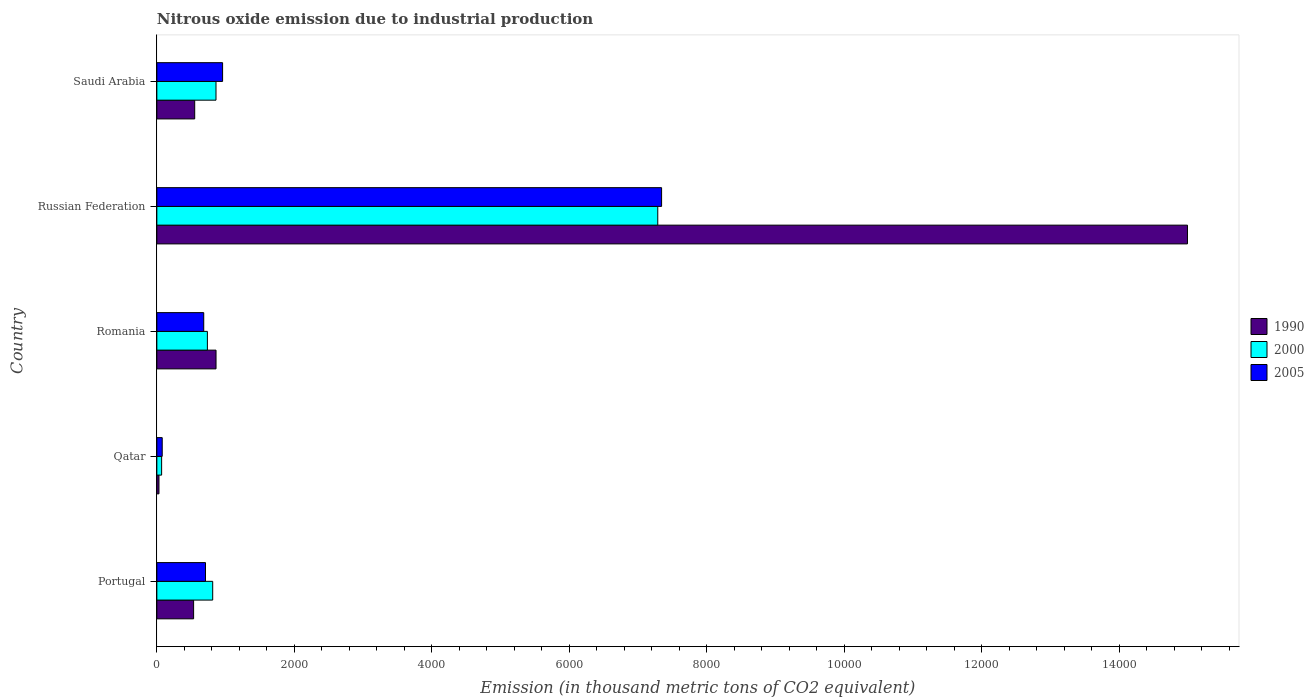How many groups of bars are there?
Ensure brevity in your answer.  5. How many bars are there on the 3rd tick from the bottom?
Your answer should be compact. 3. What is the label of the 4th group of bars from the top?
Make the answer very short. Qatar. What is the amount of nitrous oxide emitted in 2000 in Qatar?
Offer a terse response. 69.5. Across all countries, what is the maximum amount of nitrous oxide emitted in 1990?
Your answer should be compact. 1.50e+04. Across all countries, what is the minimum amount of nitrous oxide emitted in 2005?
Provide a short and direct response. 78.2. In which country was the amount of nitrous oxide emitted in 2000 maximum?
Provide a succinct answer. Russian Federation. In which country was the amount of nitrous oxide emitted in 2005 minimum?
Your response must be concise. Qatar. What is the total amount of nitrous oxide emitted in 2000 in the graph?
Offer a terse response. 9766.6. What is the difference between the amount of nitrous oxide emitted in 2005 in Qatar and that in Saudi Arabia?
Offer a terse response. -878.5. What is the difference between the amount of nitrous oxide emitted in 2000 in Qatar and the amount of nitrous oxide emitted in 2005 in Portugal?
Provide a succinct answer. -638.5. What is the average amount of nitrous oxide emitted in 2000 per country?
Your response must be concise. 1953.32. What is the difference between the amount of nitrous oxide emitted in 2005 and amount of nitrous oxide emitted in 1990 in Portugal?
Offer a very short reply. 173.1. What is the ratio of the amount of nitrous oxide emitted in 2005 in Russian Federation to that in Saudi Arabia?
Keep it short and to the point. 7.68. Is the amount of nitrous oxide emitted in 1990 in Portugal less than that in Russian Federation?
Provide a short and direct response. Yes. What is the difference between the highest and the second highest amount of nitrous oxide emitted in 1990?
Your answer should be compact. 1.41e+04. What is the difference between the highest and the lowest amount of nitrous oxide emitted in 1990?
Keep it short and to the point. 1.50e+04. What does the 1st bar from the top in Qatar represents?
Your answer should be very brief. 2005. Is it the case that in every country, the sum of the amount of nitrous oxide emitted in 2005 and amount of nitrous oxide emitted in 1990 is greater than the amount of nitrous oxide emitted in 2000?
Your response must be concise. Yes. How many bars are there?
Give a very brief answer. 15. Are all the bars in the graph horizontal?
Provide a short and direct response. Yes. Are the values on the major ticks of X-axis written in scientific E-notation?
Your response must be concise. No. Does the graph contain any zero values?
Your answer should be very brief. No. Does the graph contain grids?
Your answer should be very brief. No. How are the legend labels stacked?
Offer a very short reply. Vertical. What is the title of the graph?
Offer a terse response. Nitrous oxide emission due to industrial production. What is the label or title of the X-axis?
Your answer should be compact. Emission (in thousand metric tons of CO2 equivalent). What is the label or title of the Y-axis?
Offer a terse response. Country. What is the Emission (in thousand metric tons of CO2 equivalent) in 1990 in Portugal?
Keep it short and to the point. 534.9. What is the Emission (in thousand metric tons of CO2 equivalent) in 2000 in Portugal?
Your answer should be very brief. 812.7. What is the Emission (in thousand metric tons of CO2 equivalent) in 2005 in Portugal?
Offer a terse response. 708. What is the Emission (in thousand metric tons of CO2 equivalent) in 1990 in Qatar?
Provide a succinct answer. 30.8. What is the Emission (in thousand metric tons of CO2 equivalent) of 2000 in Qatar?
Offer a terse response. 69.5. What is the Emission (in thousand metric tons of CO2 equivalent) in 2005 in Qatar?
Your answer should be very brief. 78.2. What is the Emission (in thousand metric tons of CO2 equivalent) in 1990 in Romania?
Your response must be concise. 861.1. What is the Emission (in thousand metric tons of CO2 equivalent) of 2000 in Romania?
Provide a succinct answer. 735.3. What is the Emission (in thousand metric tons of CO2 equivalent) in 2005 in Romania?
Give a very brief answer. 682.3. What is the Emission (in thousand metric tons of CO2 equivalent) in 1990 in Russian Federation?
Your answer should be very brief. 1.50e+04. What is the Emission (in thousand metric tons of CO2 equivalent) of 2000 in Russian Federation?
Give a very brief answer. 7288.4. What is the Emission (in thousand metric tons of CO2 equivalent) of 2005 in Russian Federation?
Offer a terse response. 7344.1. What is the Emission (in thousand metric tons of CO2 equivalent) of 1990 in Saudi Arabia?
Give a very brief answer. 550.9. What is the Emission (in thousand metric tons of CO2 equivalent) of 2000 in Saudi Arabia?
Provide a succinct answer. 860.7. What is the Emission (in thousand metric tons of CO2 equivalent) in 2005 in Saudi Arabia?
Your answer should be very brief. 956.7. Across all countries, what is the maximum Emission (in thousand metric tons of CO2 equivalent) of 1990?
Give a very brief answer. 1.50e+04. Across all countries, what is the maximum Emission (in thousand metric tons of CO2 equivalent) in 2000?
Give a very brief answer. 7288.4. Across all countries, what is the maximum Emission (in thousand metric tons of CO2 equivalent) in 2005?
Provide a succinct answer. 7344.1. Across all countries, what is the minimum Emission (in thousand metric tons of CO2 equivalent) in 1990?
Your response must be concise. 30.8. Across all countries, what is the minimum Emission (in thousand metric tons of CO2 equivalent) in 2000?
Keep it short and to the point. 69.5. Across all countries, what is the minimum Emission (in thousand metric tons of CO2 equivalent) in 2005?
Your answer should be compact. 78.2. What is the total Emission (in thousand metric tons of CO2 equivalent) of 1990 in the graph?
Provide a short and direct response. 1.70e+04. What is the total Emission (in thousand metric tons of CO2 equivalent) of 2000 in the graph?
Keep it short and to the point. 9766.6. What is the total Emission (in thousand metric tons of CO2 equivalent) in 2005 in the graph?
Your answer should be compact. 9769.3. What is the difference between the Emission (in thousand metric tons of CO2 equivalent) in 1990 in Portugal and that in Qatar?
Ensure brevity in your answer.  504.1. What is the difference between the Emission (in thousand metric tons of CO2 equivalent) of 2000 in Portugal and that in Qatar?
Make the answer very short. 743.2. What is the difference between the Emission (in thousand metric tons of CO2 equivalent) in 2005 in Portugal and that in Qatar?
Offer a terse response. 629.8. What is the difference between the Emission (in thousand metric tons of CO2 equivalent) in 1990 in Portugal and that in Romania?
Provide a short and direct response. -326.2. What is the difference between the Emission (in thousand metric tons of CO2 equivalent) in 2000 in Portugal and that in Romania?
Offer a terse response. 77.4. What is the difference between the Emission (in thousand metric tons of CO2 equivalent) in 2005 in Portugal and that in Romania?
Provide a succinct answer. 25.7. What is the difference between the Emission (in thousand metric tons of CO2 equivalent) in 1990 in Portugal and that in Russian Federation?
Give a very brief answer. -1.45e+04. What is the difference between the Emission (in thousand metric tons of CO2 equivalent) of 2000 in Portugal and that in Russian Federation?
Offer a terse response. -6475.7. What is the difference between the Emission (in thousand metric tons of CO2 equivalent) of 2005 in Portugal and that in Russian Federation?
Your answer should be compact. -6636.1. What is the difference between the Emission (in thousand metric tons of CO2 equivalent) of 1990 in Portugal and that in Saudi Arabia?
Make the answer very short. -16. What is the difference between the Emission (in thousand metric tons of CO2 equivalent) in 2000 in Portugal and that in Saudi Arabia?
Offer a very short reply. -48. What is the difference between the Emission (in thousand metric tons of CO2 equivalent) in 2005 in Portugal and that in Saudi Arabia?
Provide a short and direct response. -248.7. What is the difference between the Emission (in thousand metric tons of CO2 equivalent) in 1990 in Qatar and that in Romania?
Provide a short and direct response. -830.3. What is the difference between the Emission (in thousand metric tons of CO2 equivalent) of 2000 in Qatar and that in Romania?
Keep it short and to the point. -665.8. What is the difference between the Emission (in thousand metric tons of CO2 equivalent) of 2005 in Qatar and that in Romania?
Your answer should be very brief. -604.1. What is the difference between the Emission (in thousand metric tons of CO2 equivalent) in 1990 in Qatar and that in Russian Federation?
Offer a very short reply. -1.50e+04. What is the difference between the Emission (in thousand metric tons of CO2 equivalent) of 2000 in Qatar and that in Russian Federation?
Keep it short and to the point. -7218.9. What is the difference between the Emission (in thousand metric tons of CO2 equivalent) of 2005 in Qatar and that in Russian Federation?
Provide a short and direct response. -7265.9. What is the difference between the Emission (in thousand metric tons of CO2 equivalent) in 1990 in Qatar and that in Saudi Arabia?
Offer a very short reply. -520.1. What is the difference between the Emission (in thousand metric tons of CO2 equivalent) of 2000 in Qatar and that in Saudi Arabia?
Make the answer very short. -791.2. What is the difference between the Emission (in thousand metric tons of CO2 equivalent) of 2005 in Qatar and that in Saudi Arabia?
Give a very brief answer. -878.5. What is the difference between the Emission (in thousand metric tons of CO2 equivalent) of 1990 in Romania and that in Russian Federation?
Offer a very short reply. -1.41e+04. What is the difference between the Emission (in thousand metric tons of CO2 equivalent) in 2000 in Romania and that in Russian Federation?
Your response must be concise. -6553.1. What is the difference between the Emission (in thousand metric tons of CO2 equivalent) of 2005 in Romania and that in Russian Federation?
Ensure brevity in your answer.  -6661.8. What is the difference between the Emission (in thousand metric tons of CO2 equivalent) in 1990 in Romania and that in Saudi Arabia?
Keep it short and to the point. 310.2. What is the difference between the Emission (in thousand metric tons of CO2 equivalent) of 2000 in Romania and that in Saudi Arabia?
Give a very brief answer. -125.4. What is the difference between the Emission (in thousand metric tons of CO2 equivalent) of 2005 in Romania and that in Saudi Arabia?
Offer a very short reply. -274.4. What is the difference between the Emission (in thousand metric tons of CO2 equivalent) of 1990 in Russian Federation and that in Saudi Arabia?
Your answer should be very brief. 1.44e+04. What is the difference between the Emission (in thousand metric tons of CO2 equivalent) of 2000 in Russian Federation and that in Saudi Arabia?
Offer a terse response. 6427.7. What is the difference between the Emission (in thousand metric tons of CO2 equivalent) in 2005 in Russian Federation and that in Saudi Arabia?
Provide a short and direct response. 6387.4. What is the difference between the Emission (in thousand metric tons of CO2 equivalent) of 1990 in Portugal and the Emission (in thousand metric tons of CO2 equivalent) of 2000 in Qatar?
Provide a short and direct response. 465.4. What is the difference between the Emission (in thousand metric tons of CO2 equivalent) in 1990 in Portugal and the Emission (in thousand metric tons of CO2 equivalent) in 2005 in Qatar?
Provide a succinct answer. 456.7. What is the difference between the Emission (in thousand metric tons of CO2 equivalent) in 2000 in Portugal and the Emission (in thousand metric tons of CO2 equivalent) in 2005 in Qatar?
Ensure brevity in your answer.  734.5. What is the difference between the Emission (in thousand metric tons of CO2 equivalent) of 1990 in Portugal and the Emission (in thousand metric tons of CO2 equivalent) of 2000 in Romania?
Your answer should be very brief. -200.4. What is the difference between the Emission (in thousand metric tons of CO2 equivalent) in 1990 in Portugal and the Emission (in thousand metric tons of CO2 equivalent) in 2005 in Romania?
Your answer should be very brief. -147.4. What is the difference between the Emission (in thousand metric tons of CO2 equivalent) in 2000 in Portugal and the Emission (in thousand metric tons of CO2 equivalent) in 2005 in Romania?
Ensure brevity in your answer.  130.4. What is the difference between the Emission (in thousand metric tons of CO2 equivalent) of 1990 in Portugal and the Emission (in thousand metric tons of CO2 equivalent) of 2000 in Russian Federation?
Ensure brevity in your answer.  -6753.5. What is the difference between the Emission (in thousand metric tons of CO2 equivalent) in 1990 in Portugal and the Emission (in thousand metric tons of CO2 equivalent) in 2005 in Russian Federation?
Ensure brevity in your answer.  -6809.2. What is the difference between the Emission (in thousand metric tons of CO2 equivalent) of 2000 in Portugal and the Emission (in thousand metric tons of CO2 equivalent) of 2005 in Russian Federation?
Ensure brevity in your answer.  -6531.4. What is the difference between the Emission (in thousand metric tons of CO2 equivalent) in 1990 in Portugal and the Emission (in thousand metric tons of CO2 equivalent) in 2000 in Saudi Arabia?
Give a very brief answer. -325.8. What is the difference between the Emission (in thousand metric tons of CO2 equivalent) in 1990 in Portugal and the Emission (in thousand metric tons of CO2 equivalent) in 2005 in Saudi Arabia?
Offer a terse response. -421.8. What is the difference between the Emission (in thousand metric tons of CO2 equivalent) in 2000 in Portugal and the Emission (in thousand metric tons of CO2 equivalent) in 2005 in Saudi Arabia?
Provide a succinct answer. -144. What is the difference between the Emission (in thousand metric tons of CO2 equivalent) in 1990 in Qatar and the Emission (in thousand metric tons of CO2 equivalent) in 2000 in Romania?
Your response must be concise. -704.5. What is the difference between the Emission (in thousand metric tons of CO2 equivalent) of 1990 in Qatar and the Emission (in thousand metric tons of CO2 equivalent) of 2005 in Romania?
Make the answer very short. -651.5. What is the difference between the Emission (in thousand metric tons of CO2 equivalent) in 2000 in Qatar and the Emission (in thousand metric tons of CO2 equivalent) in 2005 in Romania?
Offer a very short reply. -612.8. What is the difference between the Emission (in thousand metric tons of CO2 equivalent) in 1990 in Qatar and the Emission (in thousand metric tons of CO2 equivalent) in 2000 in Russian Federation?
Provide a succinct answer. -7257.6. What is the difference between the Emission (in thousand metric tons of CO2 equivalent) in 1990 in Qatar and the Emission (in thousand metric tons of CO2 equivalent) in 2005 in Russian Federation?
Ensure brevity in your answer.  -7313.3. What is the difference between the Emission (in thousand metric tons of CO2 equivalent) in 2000 in Qatar and the Emission (in thousand metric tons of CO2 equivalent) in 2005 in Russian Federation?
Your answer should be very brief. -7274.6. What is the difference between the Emission (in thousand metric tons of CO2 equivalent) in 1990 in Qatar and the Emission (in thousand metric tons of CO2 equivalent) in 2000 in Saudi Arabia?
Provide a succinct answer. -829.9. What is the difference between the Emission (in thousand metric tons of CO2 equivalent) in 1990 in Qatar and the Emission (in thousand metric tons of CO2 equivalent) in 2005 in Saudi Arabia?
Keep it short and to the point. -925.9. What is the difference between the Emission (in thousand metric tons of CO2 equivalent) in 2000 in Qatar and the Emission (in thousand metric tons of CO2 equivalent) in 2005 in Saudi Arabia?
Give a very brief answer. -887.2. What is the difference between the Emission (in thousand metric tons of CO2 equivalent) of 1990 in Romania and the Emission (in thousand metric tons of CO2 equivalent) of 2000 in Russian Federation?
Your answer should be compact. -6427.3. What is the difference between the Emission (in thousand metric tons of CO2 equivalent) in 1990 in Romania and the Emission (in thousand metric tons of CO2 equivalent) in 2005 in Russian Federation?
Your answer should be very brief. -6483. What is the difference between the Emission (in thousand metric tons of CO2 equivalent) in 2000 in Romania and the Emission (in thousand metric tons of CO2 equivalent) in 2005 in Russian Federation?
Provide a short and direct response. -6608.8. What is the difference between the Emission (in thousand metric tons of CO2 equivalent) of 1990 in Romania and the Emission (in thousand metric tons of CO2 equivalent) of 2005 in Saudi Arabia?
Keep it short and to the point. -95.6. What is the difference between the Emission (in thousand metric tons of CO2 equivalent) in 2000 in Romania and the Emission (in thousand metric tons of CO2 equivalent) in 2005 in Saudi Arabia?
Offer a very short reply. -221.4. What is the difference between the Emission (in thousand metric tons of CO2 equivalent) of 1990 in Russian Federation and the Emission (in thousand metric tons of CO2 equivalent) of 2000 in Saudi Arabia?
Offer a very short reply. 1.41e+04. What is the difference between the Emission (in thousand metric tons of CO2 equivalent) of 1990 in Russian Federation and the Emission (in thousand metric tons of CO2 equivalent) of 2005 in Saudi Arabia?
Offer a very short reply. 1.40e+04. What is the difference between the Emission (in thousand metric tons of CO2 equivalent) of 2000 in Russian Federation and the Emission (in thousand metric tons of CO2 equivalent) of 2005 in Saudi Arabia?
Provide a short and direct response. 6331.7. What is the average Emission (in thousand metric tons of CO2 equivalent) of 1990 per country?
Give a very brief answer. 3394.6. What is the average Emission (in thousand metric tons of CO2 equivalent) of 2000 per country?
Your answer should be very brief. 1953.32. What is the average Emission (in thousand metric tons of CO2 equivalent) in 2005 per country?
Give a very brief answer. 1953.86. What is the difference between the Emission (in thousand metric tons of CO2 equivalent) of 1990 and Emission (in thousand metric tons of CO2 equivalent) of 2000 in Portugal?
Your answer should be very brief. -277.8. What is the difference between the Emission (in thousand metric tons of CO2 equivalent) in 1990 and Emission (in thousand metric tons of CO2 equivalent) in 2005 in Portugal?
Keep it short and to the point. -173.1. What is the difference between the Emission (in thousand metric tons of CO2 equivalent) in 2000 and Emission (in thousand metric tons of CO2 equivalent) in 2005 in Portugal?
Your answer should be very brief. 104.7. What is the difference between the Emission (in thousand metric tons of CO2 equivalent) of 1990 and Emission (in thousand metric tons of CO2 equivalent) of 2000 in Qatar?
Provide a short and direct response. -38.7. What is the difference between the Emission (in thousand metric tons of CO2 equivalent) in 1990 and Emission (in thousand metric tons of CO2 equivalent) in 2005 in Qatar?
Provide a short and direct response. -47.4. What is the difference between the Emission (in thousand metric tons of CO2 equivalent) of 2000 and Emission (in thousand metric tons of CO2 equivalent) of 2005 in Qatar?
Provide a succinct answer. -8.7. What is the difference between the Emission (in thousand metric tons of CO2 equivalent) in 1990 and Emission (in thousand metric tons of CO2 equivalent) in 2000 in Romania?
Provide a succinct answer. 125.8. What is the difference between the Emission (in thousand metric tons of CO2 equivalent) in 1990 and Emission (in thousand metric tons of CO2 equivalent) in 2005 in Romania?
Ensure brevity in your answer.  178.8. What is the difference between the Emission (in thousand metric tons of CO2 equivalent) in 2000 and Emission (in thousand metric tons of CO2 equivalent) in 2005 in Romania?
Keep it short and to the point. 53. What is the difference between the Emission (in thousand metric tons of CO2 equivalent) of 1990 and Emission (in thousand metric tons of CO2 equivalent) of 2000 in Russian Federation?
Your answer should be very brief. 7706.9. What is the difference between the Emission (in thousand metric tons of CO2 equivalent) of 1990 and Emission (in thousand metric tons of CO2 equivalent) of 2005 in Russian Federation?
Provide a succinct answer. 7651.2. What is the difference between the Emission (in thousand metric tons of CO2 equivalent) of 2000 and Emission (in thousand metric tons of CO2 equivalent) of 2005 in Russian Federation?
Make the answer very short. -55.7. What is the difference between the Emission (in thousand metric tons of CO2 equivalent) of 1990 and Emission (in thousand metric tons of CO2 equivalent) of 2000 in Saudi Arabia?
Offer a very short reply. -309.8. What is the difference between the Emission (in thousand metric tons of CO2 equivalent) of 1990 and Emission (in thousand metric tons of CO2 equivalent) of 2005 in Saudi Arabia?
Your answer should be very brief. -405.8. What is the difference between the Emission (in thousand metric tons of CO2 equivalent) of 2000 and Emission (in thousand metric tons of CO2 equivalent) of 2005 in Saudi Arabia?
Your answer should be compact. -96. What is the ratio of the Emission (in thousand metric tons of CO2 equivalent) in 1990 in Portugal to that in Qatar?
Your answer should be very brief. 17.37. What is the ratio of the Emission (in thousand metric tons of CO2 equivalent) of 2000 in Portugal to that in Qatar?
Offer a very short reply. 11.69. What is the ratio of the Emission (in thousand metric tons of CO2 equivalent) of 2005 in Portugal to that in Qatar?
Your answer should be compact. 9.05. What is the ratio of the Emission (in thousand metric tons of CO2 equivalent) of 1990 in Portugal to that in Romania?
Your answer should be very brief. 0.62. What is the ratio of the Emission (in thousand metric tons of CO2 equivalent) in 2000 in Portugal to that in Romania?
Provide a short and direct response. 1.11. What is the ratio of the Emission (in thousand metric tons of CO2 equivalent) of 2005 in Portugal to that in Romania?
Ensure brevity in your answer.  1.04. What is the ratio of the Emission (in thousand metric tons of CO2 equivalent) of 1990 in Portugal to that in Russian Federation?
Provide a succinct answer. 0.04. What is the ratio of the Emission (in thousand metric tons of CO2 equivalent) in 2000 in Portugal to that in Russian Federation?
Provide a short and direct response. 0.11. What is the ratio of the Emission (in thousand metric tons of CO2 equivalent) in 2005 in Portugal to that in Russian Federation?
Keep it short and to the point. 0.1. What is the ratio of the Emission (in thousand metric tons of CO2 equivalent) in 2000 in Portugal to that in Saudi Arabia?
Your answer should be compact. 0.94. What is the ratio of the Emission (in thousand metric tons of CO2 equivalent) in 2005 in Portugal to that in Saudi Arabia?
Your answer should be compact. 0.74. What is the ratio of the Emission (in thousand metric tons of CO2 equivalent) of 1990 in Qatar to that in Romania?
Provide a succinct answer. 0.04. What is the ratio of the Emission (in thousand metric tons of CO2 equivalent) of 2000 in Qatar to that in Romania?
Give a very brief answer. 0.09. What is the ratio of the Emission (in thousand metric tons of CO2 equivalent) in 2005 in Qatar to that in Romania?
Offer a terse response. 0.11. What is the ratio of the Emission (in thousand metric tons of CO2 equivalent) of 1990 in Qatar to that in Russian Federation?
Your response must be concise. 0. What is the ratio of the Emission (in thousand metric tons of CO2 equivalent) in 2000 in Qatar to that in Russian Federation?
Keep it short and to the point. 0.01. What is the ratio of the Emission (in thousand metric tons of CO2 equivalent) in 2005 in Qatar to that in Russian Federation?
Offer a terse response. 0.01. What is the ratio of the Emission (in thousand metric tons of CO2 equivalent) of 1990 in Qatar to that in Saudi Arabia?
Provide a short and direct response. 0.06. What is the ratio of the Emission (in thousand metric tons of CO2 equivalent) in 2000 in Qatar to that in Saudi Arabia?
Your answer should be very brief. 0.08. What is the ratio of the Emission (in thousand metric tons of CO2 equivalent) of 2005 in Qatar to that in Saudi Arabia?
Make the answer very short. 0.08. What is the ratio of the Emission (in thousand metric tons of CO2 equivalent) in 1990 in Romania to that in Russian Federation?
Your answer should be compact. 0.06. What is the ratio of the Emission (in thousand metric tons of CO2 equivalent) in 2000 in Romania to that in Russian Federation?
Offer a terse response. 0.1. What is the ratio of the Emission (in thousand metric tons of CO2 equivalent) in 2005 in Romania to that in Russian Federation?
Ensure brevity in your answer.  0.09. What is the ratio of the Emission (in thousand metric tons of CO2 equivalent) in 1990 in Romania to that in Saudi Arabia?
Give a very brief answer. 1.56. What is the ratio of the Emission (in thousand metric tons of CO2 equivalent) in 2000 in Romania to that in Saudi Arabia?
Ensure brevity in your answer.  0.85. What is the ratio of the Emission (in thousand metric tons of CO2 equivalent) in 2005 in Romania to that in Saudi Arabia?
Make the answer very short. 0.71. What is the ratio of the Emission (in thousand metric tons of CO2 equivalent) of 1990 in Russian Federation to that in Saudi Arabia?
Your answer should be very brief. 27.22. What is the ratio of the Emission (in thousand metric tons of CO2 equivalent) of 2000 in Russian Federation to that in Saudi Arabia?
Keep it short and to the point. 8.47. What is the ratio of the Emission (in thousand metric tons of CO2 equivalent) of 2005 in Russian Federation to that in Saudi Arabia?
Offer a very short reply. 7.68. What is the difference between the highest and the second highest Emission (in thousand metric tons of CO2 equivalent) of 1990?
Your answer should be very brief. 1.41e+04. What is the difference between the highest and the second highest Emission (in thousand metric tons of CO2 equivalent) of 2000?
Make the answer very short. 6427.7. What is the difference between the highest and the second highest Emission (in thousand metric tons of CO2 equivalent) of 2005?
Your response must be concise. 6387.4. What is the difference between the highest and the lowest Emission (in thousand metric tons of CO2 equivalent) in 1990?
Provide a succinct answer. 1.50e+04. What is the difference between the highest and the lowest Emission (in thousand metric tons of CO2 equivalent) of 2000?
Your answer should be very brief. 7218.9. What is the difference between the highest and the lowest Emission (in thousand metric tons of CO2 equivalent) in 2005?
Provide a succinct answer. 7265.9. 